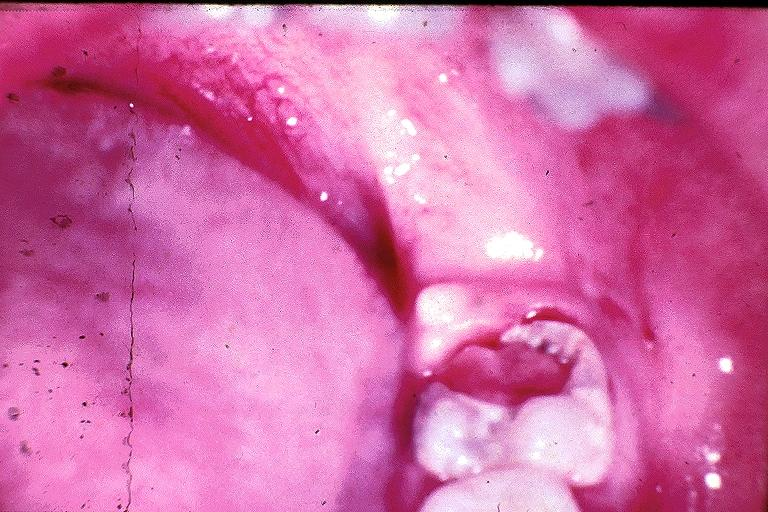where is this?
Answer the question using a single word or phrase. Oral 